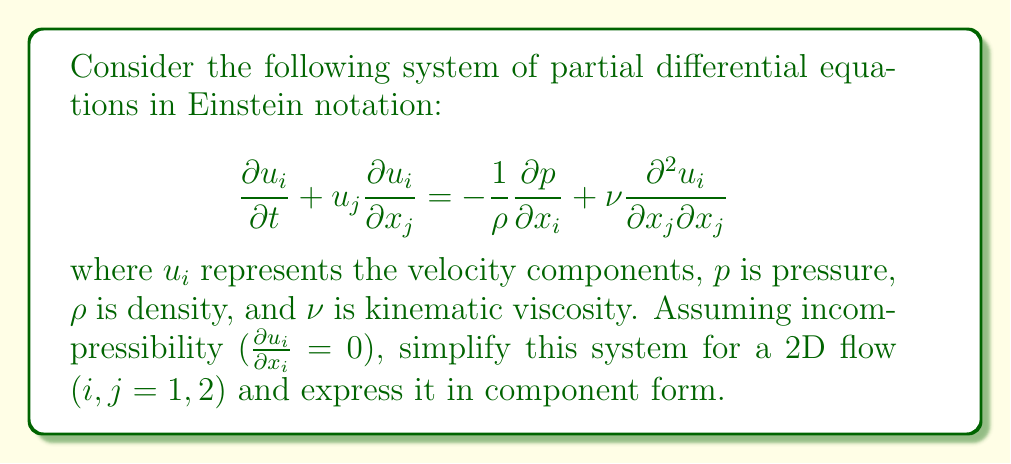Provide a solution to this math problem. Let's approach this step-by-step:

1) First, we'll expand the Einstein notation for a 2D flow ($i, j = 1, 2$):

   For $i = 1$:
   $$\frac{\partial u_1}{\partial t} + u_1 \frac{\partial u_1}{\partial x_1} + u_2 \frac{\partial u_1}{\partial x_2} = -\frac{1}{\rho}\frac{\partial p}{\partial x_1} + \nu \left(\frac{\partial^2 u_1}{\partial x_1^2} + \frac{\partial^2 u_1}{\partial x_2^2}\right)$$

   For $i = 2$:
   $$\frac{\partial u_2}{\partial t} + u_1 \frac{\partial u_2}{\partial x_1} + u_2 \frac{\partial u_2}{\partial x_2} = -\frac{1}{\rho}\frac{\partial p}{\partial x_2} + \nu \left(\frac{\partial^2 u_2}{\partial x_1^2} + \frac{\partial^2 u_2}{\partial x_2^2}\right)$$

2) The incompressibility condition in 2D is:

   $$\frac{\partial u_1}{\partial x_1} + \frac{\partial u_2}{\partial x_2} = 0$$

3) Now, let's introduce more common notation:
   $u_1 = u$, $u_2 = v$, $x_1 = x$, $x_2 = y$

4) Rewriting the equations with this notation:

   $$\frac{\partial u}{\partial t} + u \frac{\partial u}{\partial x} + v \frac{\partial u}{\partial y} = -\frac{1}{\rho}\frac{\partial p}{\partial x} + \nu \left(\frac{\partial^2 u}{\partial x^2} + \frac{\partial^2 u}{\partial y^2}\right)$$

   $$\frac{\partial v}{\partial t} + u \frac{\partial v}{\partial x} + v \frac{\partial v}{\partial y} = -\frac{1}{\rho}\frac{\partial p}{\partial y} + \nu \left(\frac{\partial^2 v}{\partial x^2} + \frac{\partial^2 v}{\partial y^2}\right)$$

   $$\frac{\partial u}{\partial x} + \frac{\partial v}{\partial y} = 0$$

These three equations form the simplified 2D incompressible Navier-Stokes equations.
Answer: $$\begin{aligned}
\frac{\partial u}{\partial t} + u \frac{\partial u}{\partial x} + v \frac{\partial u}{\partial y} &= -\frac{1}{\rho}\frac{\partial p}{\partial x} + \nu \left(\frac{\partial^2 u}{\partial x^2} + \frac{\partial^2 u}{\partial y^2}\right) \\
\frac{\partial v}{\partial t} + u \frac{\partial v}{\partial x} + v \frac{\partial v}{\partial y} &= -\frac{1}{\rho}\frac{\partial p}{\partial y} + \nu \left(\frac{\partial^2 v}{\partial x^2} + \frac{\partial^2 v}{\partial y^2}\right) \\
\frac{\partial u}{\partial x} + \frac{\partial v}{\partial y} &= 0
\end{aligned}$$ 